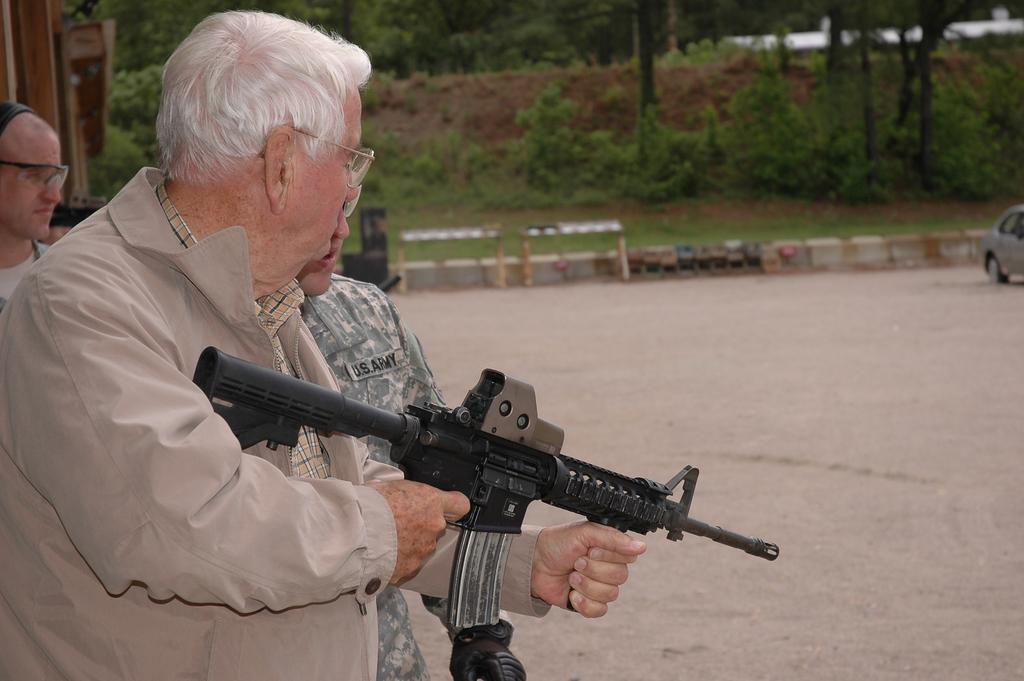How many people are in the image? There are people in the image, but the exact number is not specified. What is the man holding in the image? The man is holding a gun in the image. What is on the ground in the image? There is a car on the ground in the image. What can be seen in the background of the image? Trees, plants, and other objects are visible in the background of the image. Where is the basin located in the image? There is no basin present in the image. What type of cannon is being used to attack the car in the image? There is no cannon or attack present in the image; it only shows people, a man holding a gun, a car on the ground, and objects in the background. 